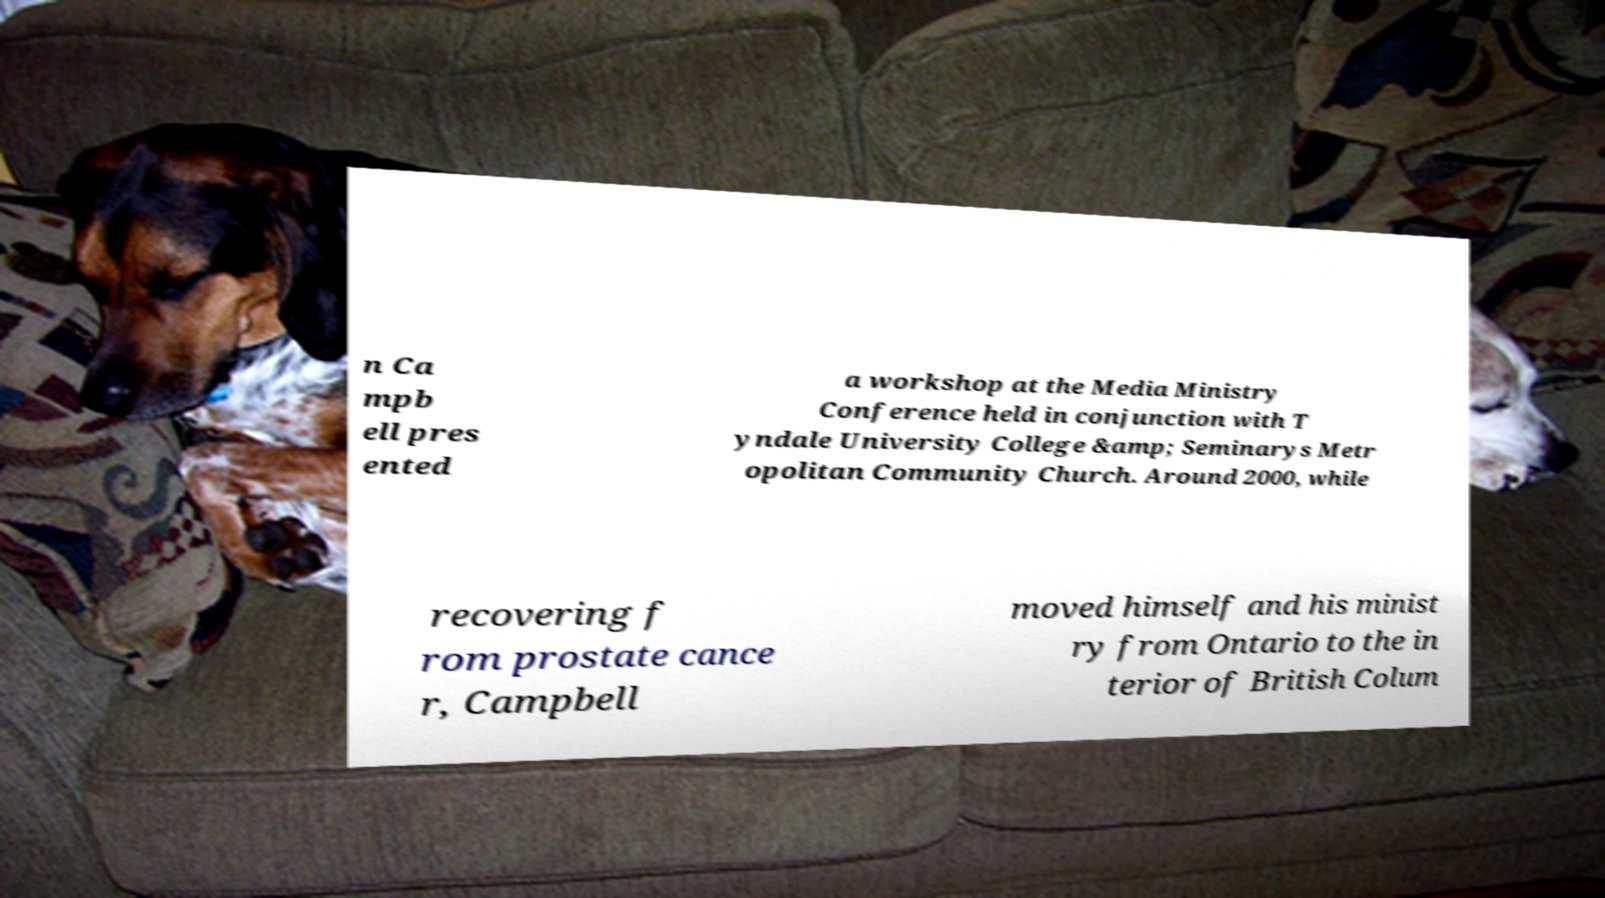I need the written content from this picture converted into text. Can you do that? n Ca mpb ell pres ented a workshop at the Media Ministry Conference held in conjunction with T yndale University College &amp; Seminarys Metr opolitan Community Church. Around 2000, while recovering f rom prostate cance r, Campbell moved himself and his minist ry from Ontario to the in terior of British Colum 